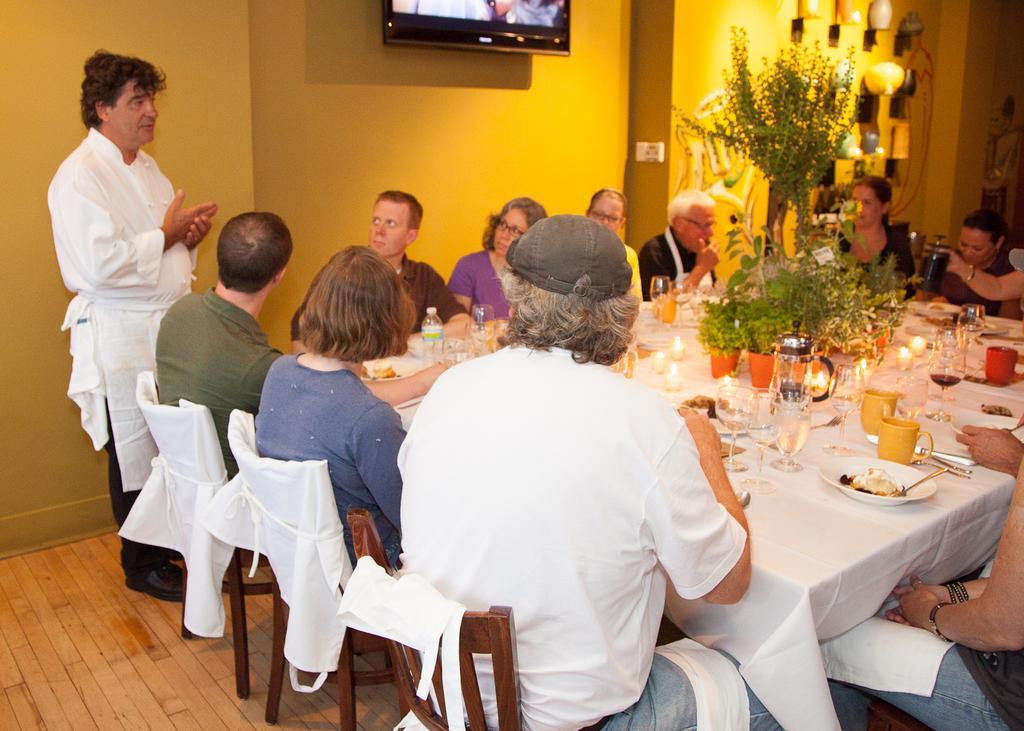How would you summarize this image in a sentence or two? It´s a closed room where number of people are seated on the chairs and in front of them there is a big table where glasses,cups and plates with spoons and food is present and in the right corner of the picture a person is standing wearing white dress,behind him there is a wall in yellow colour and a tv is present on the wall and there are some things attached to the wall and in the right corner of the picture a person who is wearing white shirt also wearing a cap and there are candles on the table and some plants too. 